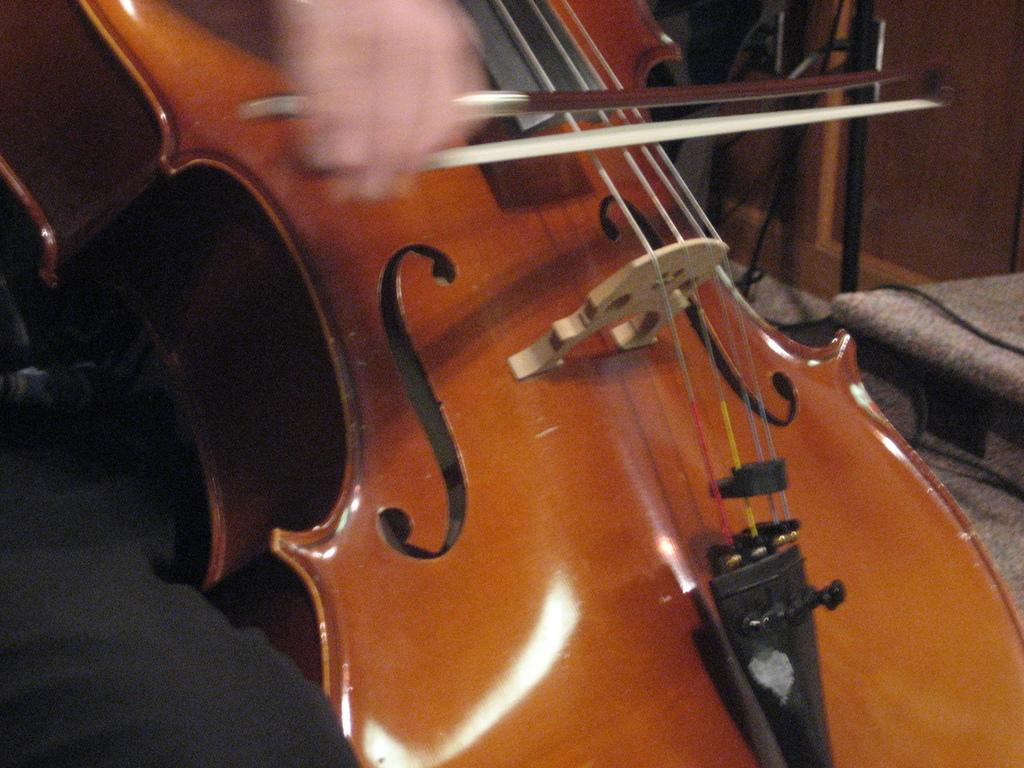What musical instrument is in the image? There is a violin in the image. What part of the violin is visible? The backside of the violin is visible. What type of door can be seen in the image? There is a wooden door in the image. What else is present in the image besides the violin and door? Cables are present in the image. How many ants can be seen crawling on the violin in the image? There are no ants present in the image; it only features a violin, a wooden door, and cables. What type of teeth can be seen on the violin in the image? Violins do not have teeth, so there are no teeth visible on the violin in the image. 